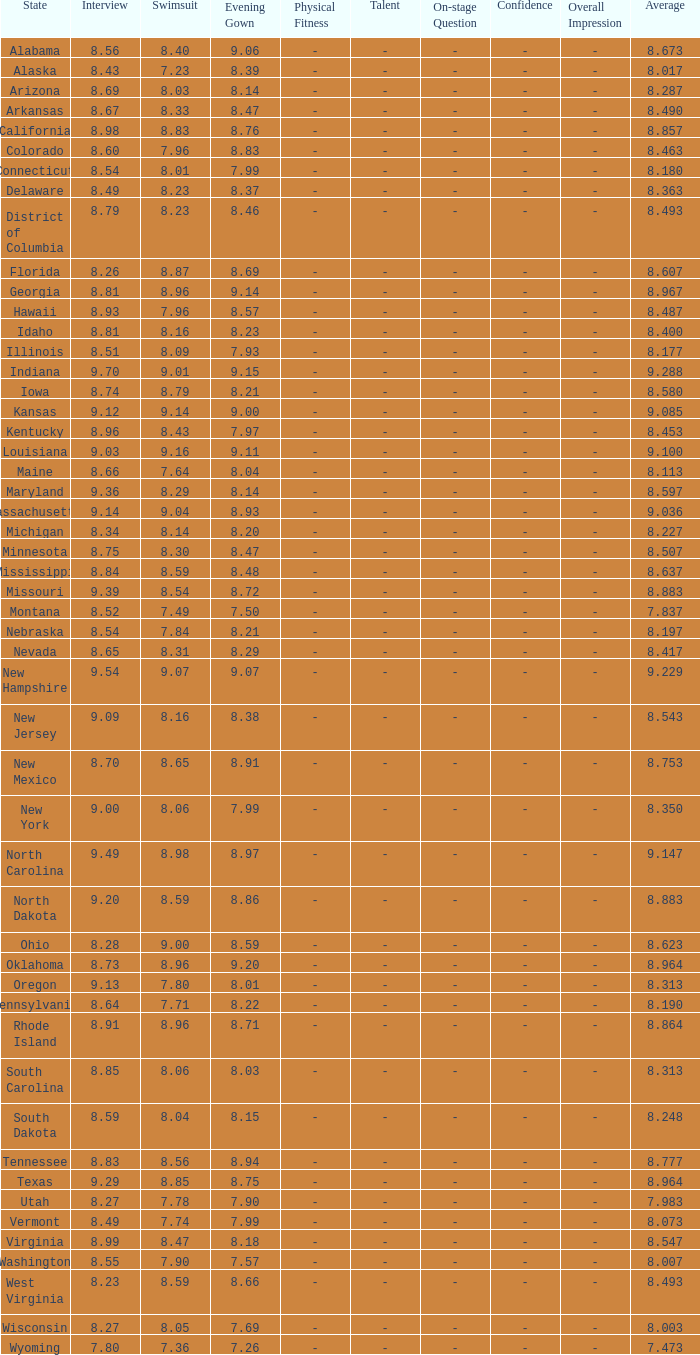Name the state with an evening gown more than 8.86 and interview less than 8.7 and swimsuit less than 8.96 Alabama. 